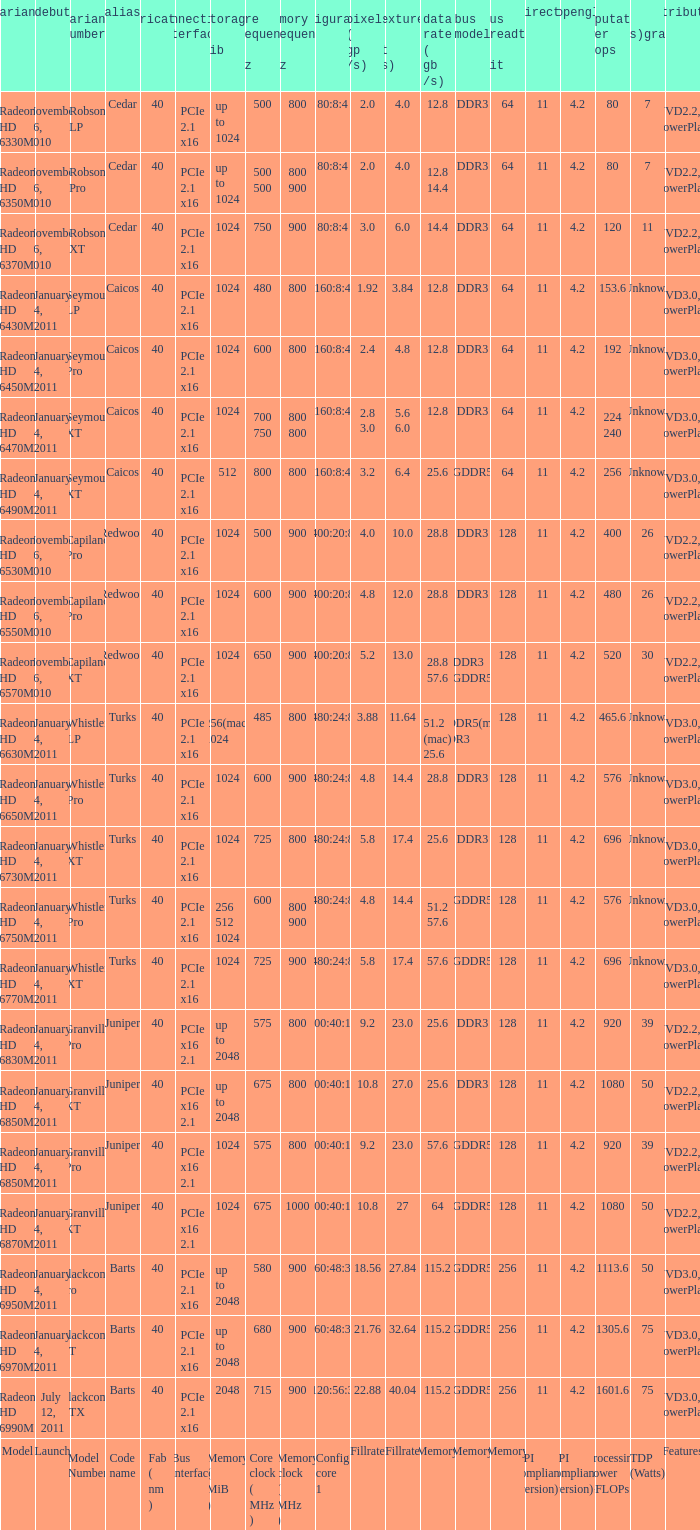How many values for fab(nm) if the model number is Whistler LP? 1.0. I'm looking to parse the entire table for insights. Could you assist me with that? {'header': ['variant', 'debut', 'variant number', 'alias', 'fabrication ( nm )', 'connection interface', 'storage ( mib )', 'core frequency ( mhz )', 'memory frequency ( mhz )', 'configuration core 1', 'pixels ( gp /s)', 'textures ( gt /s)', 'data rate ( gb /s)', 'bus model', 'bus breadth ( bit )', 'directx', 'opengl', 'computation power gflops', 'tdp (watts)graphics unit only', 'attributes'], 'rows': [['Radeon HD 6330M', 'November 26, 2010', 'Robson LP', 'Cedar', '40', 'PCIe 2.1 x16', 'up to 1024', '500', '800', '80:8:4', '2.0', '4.0', '12.8', 'DDR3', '64', '11', '4.2', '80', '7', 'UVD2.2, PowerPlay'], ['Radeon HD 6350M', 'November 26, 2010', 'Robson Pro', 'Cedar', '40', 'PCIe 2.1 x16', 'up to 1024', '500 500', '800 900', '80:8:4', '2.0', '4.0', '12.8 14.4', 'DDR3', '64', '11', '4.2', '80', '7', 'UVD2.2, PowerPlay'], ['Radeon HD 6370M', 'November 26, 2010', 'Robson XT', 'Cedar', '40', 'PCIe 2.1 x16', '1024', '750', '900', '80:8:4', '3.0', '6.0', '14.4', 'DDR3', '64', '11', '4.2', '120', '11', 'UVD2.2, PowerPlay'], ['Radeon HD 6430M', 'January 4, 2011', 'Seymour LP', 'Caicos', '40', 'PCIe 2.1 x16', '1024', '480', '800', '160:8:4', '1.92', '3.84', '12.8', 'DDR3', '64', '11', '4.2', '153.6', 'Unknown', 'UVD3.0, PowerPlay'], ['Radeon HD 6450M', 'January 4, 2011', 'Seymour Pro', 'Caicos', '40', 'PCIe 2.1 x16', '1024', '600', '800', '160:8:4', '2.4', '4.8', '12.8', 'DDR3', '64', '11', '4.2', '192', 'Unknown', 'UVD3.0, PowerPlay'], ['Radeon HD 6470M', 'January 4, 2011', 'Seymour XT', 'Caicos', '40', 'PCIe 2.1 x16', '1024', '700 750', '800 800', '160:8:4', '2.8 3.0', '5.6 6.0', '12.8', 'DDR3', '64', '11', '4.2', '224 240', 'Unknown', 'UVD3.0, PowerPlay'], ['Radeon HD 6490M', 'January 4, 2011', 'Seymour XT', 'Caicos', '40', 'PCIe 2.1 x16', '512', '800', '800', '160:8:4', '3.2', '6.4', '25.6', 'GDDR5', '64', '11', '4.2', '256', 'Unknown', 'UVD3.0, PowerPlay'], ['Radeon HD 6530M', 'November 26, 2010', 'Capilano Pro', 'Redwood', '40', 'PCIe 2.1 x16', '1024', '500', '900', '400:20:8', '4.0', '10.0', '28.8', 'DDR3', '128', '11', '4.2', '400', '26', 'UVD2.2, PowerPlay'], ['Radeon HD 6550M', 'November 26, 2010', 'Capilano Pro', 'Redwood', '40', 'PCIe 2.1 x16', '1024', '600', '900', '400:20:8', '4.8', '12.0', '28.8', 'DDR3', '128', '11', '4.2', '480', '26', 'UVD2.2, PowerPlay'], ['Radeon HD 6570M', 'November 26, 2010', 'Capilano XT', 'Redwood', '40', 'PCIe 2.1 x16', '1024', '650', '900', '400:20:8', '5.2', '13.0', '28.8 57.6', 'DDR3 GDDR5', '128', '11', '4.2', '520', '30', 'UVD2.2, PowerPlay'], ['Radeon HD 6630M', 'January 4, 2011', 'Whistler LP', 'Turks', '40', 'PCIe 2.1 x16', '256(mac) 1024', '485', '800', '480:24:8', '3.88', '11.64', '51.2 (mac) 25.6', 'GDDR5(mac) DDR3', '128', '11', '4.2', '465.6', 'Unknown', 'UVD3.0, PowerPlay'], ['Radeon HD 6650M', 'January 4, 2011', 'Whistler Pro', 'Turks', '40', 'PCIe 2.1 x16', '1024', '600', '900', '480:24:8', '4.8', '14.4', '28.8', 'DDR3', '128', '11', '4.2', '576', 'Unknown', 'UVD3.0, PowerPlay'], ['Radeon HD 6730M', 'January 4, 2011', 'Whistler XT', 'Turks', '40', 'PCIe 2.1 x16', '1024', '725', '800', '480:24:8', '5.8', '17.4', '25.6', 'DDR3', '128', '11', '4.2', '696', 'Unknown', 'UVD3.0, PowerPlay'], ['Radeon HD 6750M', 'January 4, 2011', 'Whistler Pro', 'Turks', '40', 'PCIe 2.1 x16', '256 512 1024', '600', '800 900', '480:24:8', '4.8', '14.4', '51.2 57.6', 'GDDR5', '128', '11', '4.2', '576', 'Unknown', 'UVD3.0, PowerPlay'], ['Radeon HD 6770M', 'January 4, 2011', 'Whistler XT', 'Turks', '40', 'PCIe 2.1 x16', '1024', '725', '900', '480:24:8', '5.8', '17.4', '57.6', 'GDDR5', '128', '11', '4.2', '696', 'Unknown', 'UVD3.0, PowerPlay'], ['Radeon HD 6830M', 'January 4, 2011', 'Granville Pro', 'Juniper', '40', 'PCIe x16 2.1', 'up to 2048', '575', '800', '800:40:16', '9.2', '23.0', '25.6', 'DDR3', '128', '11', '4.2', '920', '39', 'UVD2.2, PowerPlay'], ['Radeon HD 6850M', 'January 4, 2011', 'Granville XT', 'Juniper', '40', 'PCIe x16 2.1', 'up to 2048', '675', '800', '800:40:16', '10.8', '27.0', '25.6', 'DDR3', '128', '11', '4.2', '1080', '50', 'UVD2.2, PowerPlay'], ['Radeon HD 6850M', 'January 4, 2011', 'Granville Pro', 'Juniper', '40', 'PCIe x16 2.1', '1024', '575', '800', '800:40:16', '9.2', '23.0', '57.6', 'GDDR5', '128', '11', '4.2', '920', '39', 'UVD2.2, PowerPlay'], ['Radeon HD 6870M', 'January 4, 2011', 'Granville XT', 'Juniper', '40', 'PCIe x16 2.1', '1024', '675', '1000', '800:40:16', '10.8', '27', '64', 'GDDR5', '128', '11', '4.2', '1080', '50', 'UVD2.2, PowerPlay'], ['Radeon HD 6950M', 'January 4, 2011', 'Blackcomb Pro', 'Barts', '40', 'PCIe 2.1 x16', 'up to 2048', '580', '900', '960:48:32', '18.56', '27.84', '115.2', 'GDDR5', '256', '11', '4.2', '1113.6', '50', 'UVD3.0, PowerPlay'], ['Radeon HD 6970M', 'January 4, 2011', 'Blackcomb XT', 'Barts', '40', 'PCIe 2.1 x16', 'up to 2048', '680', '900', '960:48:32', '21.76', '32.64', '115.2', 'GDDR5', '256', '11', '4.2', '1305.6', '75', 'UVD3.0, PowerPlay'], ['Radeon HD 6990M', 'July 12, 2011', 'Blackcomb XTX', 'Barts', '40', 'PCIe 2.1 x16', '2048', '715', '900', '1120:56:32', '22.88', '40.04', '115.2', 'GDDR5', '256', '11', '4.2', '1601.6', '75', 'UVD3.0, PowerPlay'], ['Model', 'Launch', 'Model Number', 'Code name', 'Fab ( nm )', 'Bus interface', 'Memory ( MiB )', 'Core clock ( MHz )', 'Memory clock ( MHz )', 'Config core 1', 'Fillrate', 'Fillrate', 'Memory', 'Memory', 'Memory', 'API compliance (version)', 'API compliance (version)', 'Processing Power GFLOPs', 'TDP (Watts)', 'Features']]} 